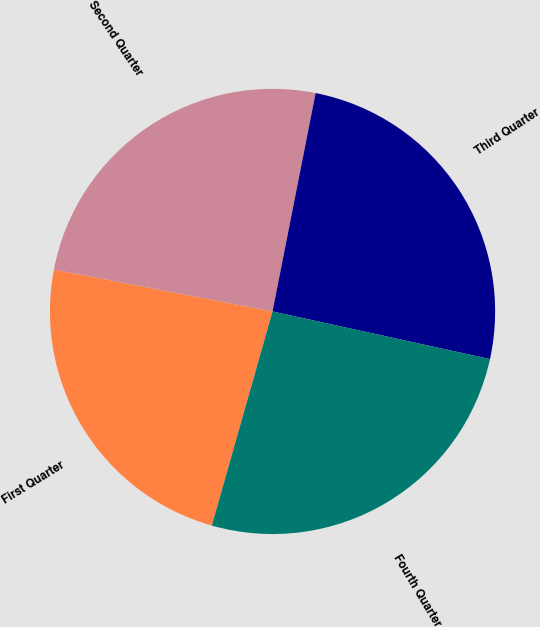Convert chart. <chart><loc_0><loc_0><loc_500><loc_500><pie_chart><fcel>First Quarter<fcel>Second Quarter<fcel>Third Quarter<fcel>Fourth Quarter<nl><fcel>23.61%<fcel>25.09%<fcel>25.33%<fcel>25.96%<nl></chart> 